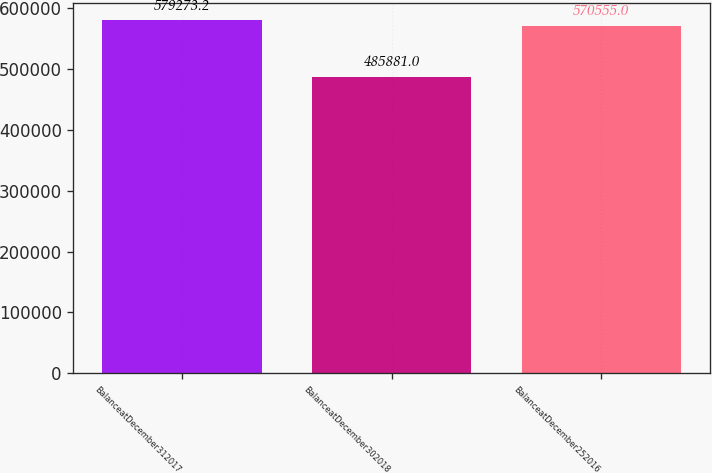Convert chart. <chart><loc_0><loc_0><loc_500><loc_500><bar_chart><fcel>BalanceatDecember312017<fcel>BalanceatDecember302018<fcel>BalanceatDecember252016<nl><fcel>579273<fcel>485881<fcel>570555<nl></chart> 